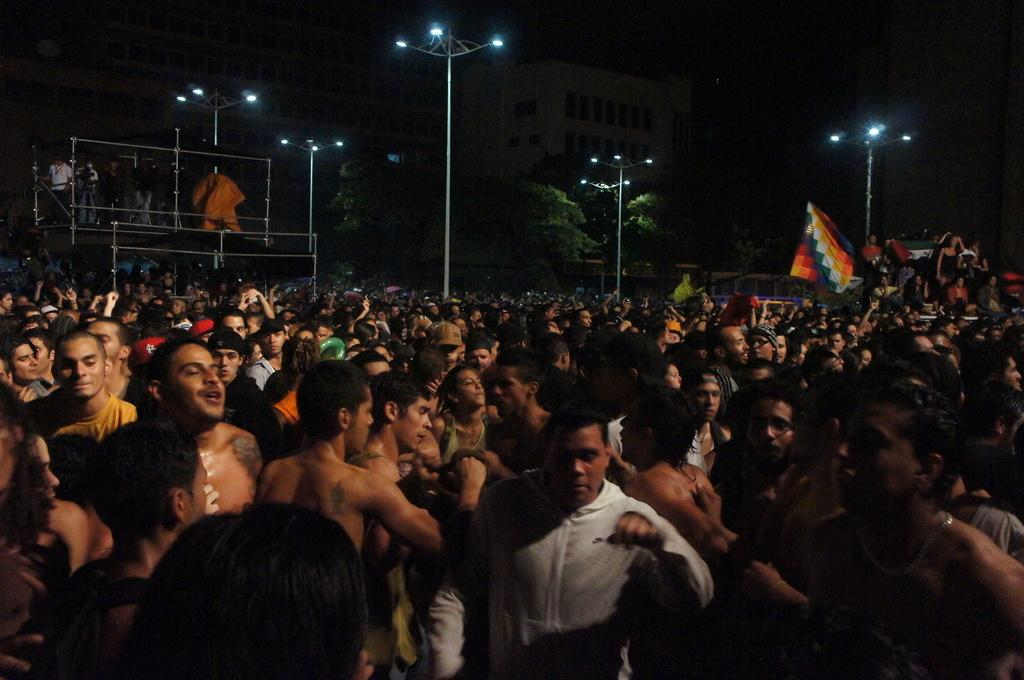What can be seen in the image involving people? There are people standing in the image. What objects are present in the image that are related to poles? There are poles in the image. What can be seen in the image that provides illumination? There are lights in the image. What is the flag's location in the image? There is a flag in the image. What type of natural elements are present in the image? There are trees in the image. What type of structures can be seen in the background of the image? There are buildings in the background of the image. How long does it take for the flame to burn out in the image? There is no flame present in the image. How many kicks can be seen being performed in the image? There is no kicking activity depicted in the image. 